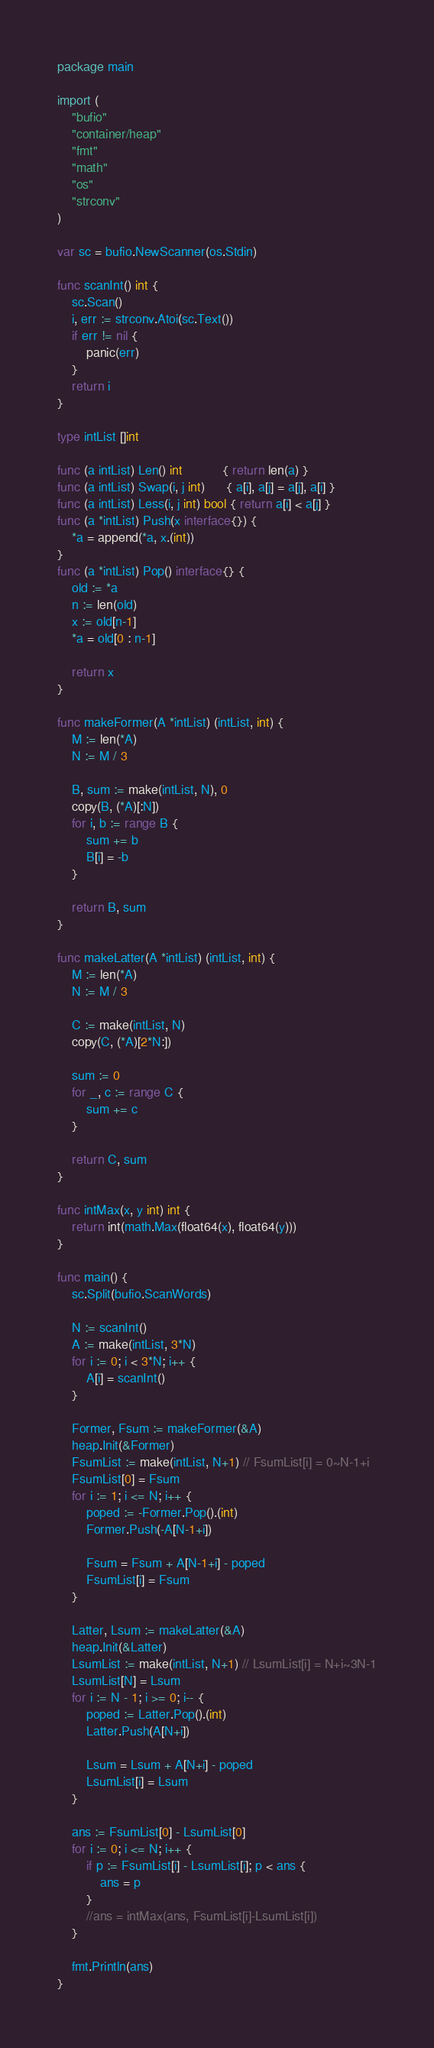Convert code to text. <code><loc_0><loc_0><loc_500><loc_500><_Go_>package main

import (
	"bufio"
	"container/heap"
	"fmt"
	"math"
	"os"
	"strconv"
)

var sc = bufio.NewScanner(os.Stdin)

func scanInt() int {
	sc.Scan()
	i, err := strconv.Atoi(sc.Text())
	if err != nil {
		panic(err)
	}
	return i
}

type intList []int

func (a intList) Len() int           { return len(a) }
func (a intList) Swap(i, j int)      { a[i], a[j] = a[j], a[i] }
func (a intList) Less(i, j int) bool { return a[i] < a[j] }
func (a *intList) Push(x interface{}) {
	*a = append(*a, x.(int))
}
func (a *intList) Pop() interface{} {
	old := *a
	n := len(old)
	x := old[n-1]
	*a = old[0 : n-1]

	return x
}

func makeFormer(A *intList) (intList, int) {
	M := len(*A)
	N := M / 3

	B, sum := make(intList, N), 0
	copy(B, (*A)[:N])
	for i, b := range B {
		sum += b
		B[i] = -b
	}

	return B, sum
}

func makeLatter(A *intList) (intList, int) {
	M := len(*A)
	N := M / 3

	C := make(intList, N)
	copy(C, (*A)[2*N:])

	sum := 0
	for _, c := range C {
		sum += c
	}

	return C, sum
}

func intMax(x, y int) int {
	return int(math.Max(float64(x), float64(y)))
}

func main() {
	sc.Split(bufio.ScanWords)

	N := scanInt()
	A := make(intList, 3*N)
	for i := 0; i < 3*N; i++ {
		A[i] = scanInt()
	}

	Former, Fsum := makeFormer(&A)
	heap.Init(&Former)
	FsumList := make(intList, N+1) // FsumList[i] = 0~N-1+i
	FsumList[0] = Fsum
	for i := 1; i <= N; i++ {
		poped := -Former.Pop().(int)
		Former.Push(-A[N-1+i])

		Fsum = Fsum + A[N-1+i] - poped
		FsumList[i] = Fsum
	}

	Latter, Lsum := makeLatter(&A)
	heap.Init(&Latter)
	LsumList := make(intList, N+1) // LsumList[i] = N+i~3N-1
	LsumList[N] = Lsum
	for i := N - 1; i >= 0; i-- {
		poped := Latter.Pop().(int)
		Latter.Push(A[N+i])

		Lsum = Lsum + A[N+i] - poped
		LsumList[i] = Lsum
	}

	ans := FsumList[0] - LsumList[0]
	for i := 0; i <= N; i++ {
		if p := FsumList[i] - LsumList[i]; p < ans {
			ans = p
		}
		//ans = intMax(ans, FsumList[i]-LsumList[i])
	}

	fmt.Println(ans)
}
</code> 